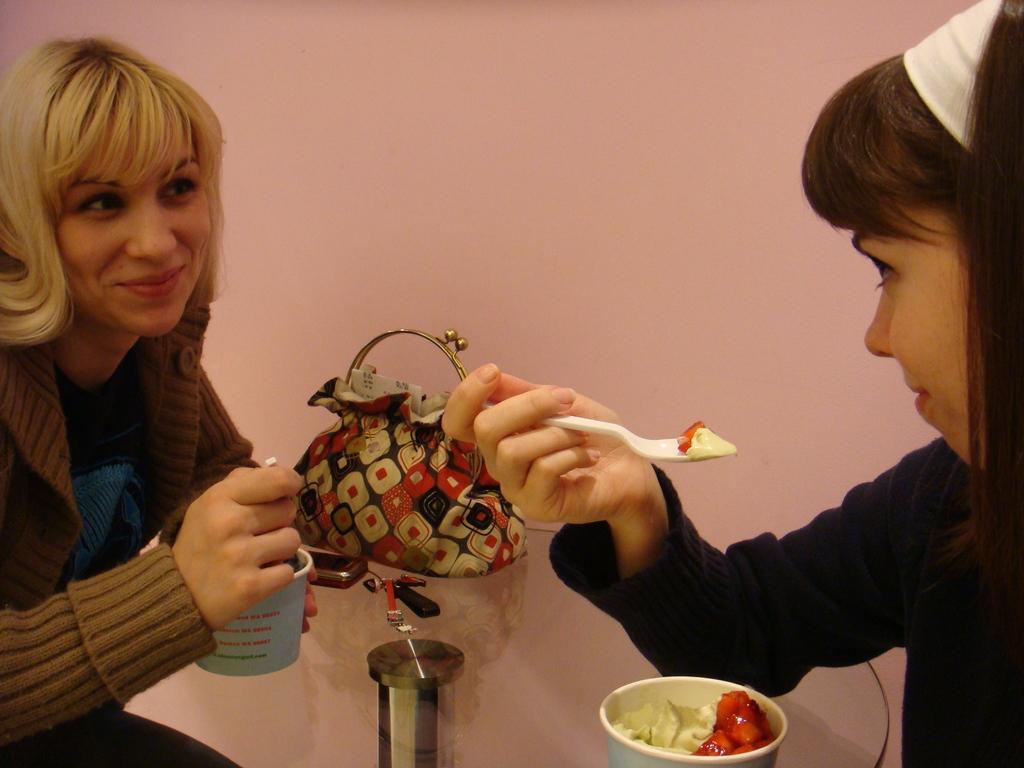How would you summarize this image in a sentence or two? On the left a woman is holding a food cup and smiling. In the right a girl is holding a spoon. 